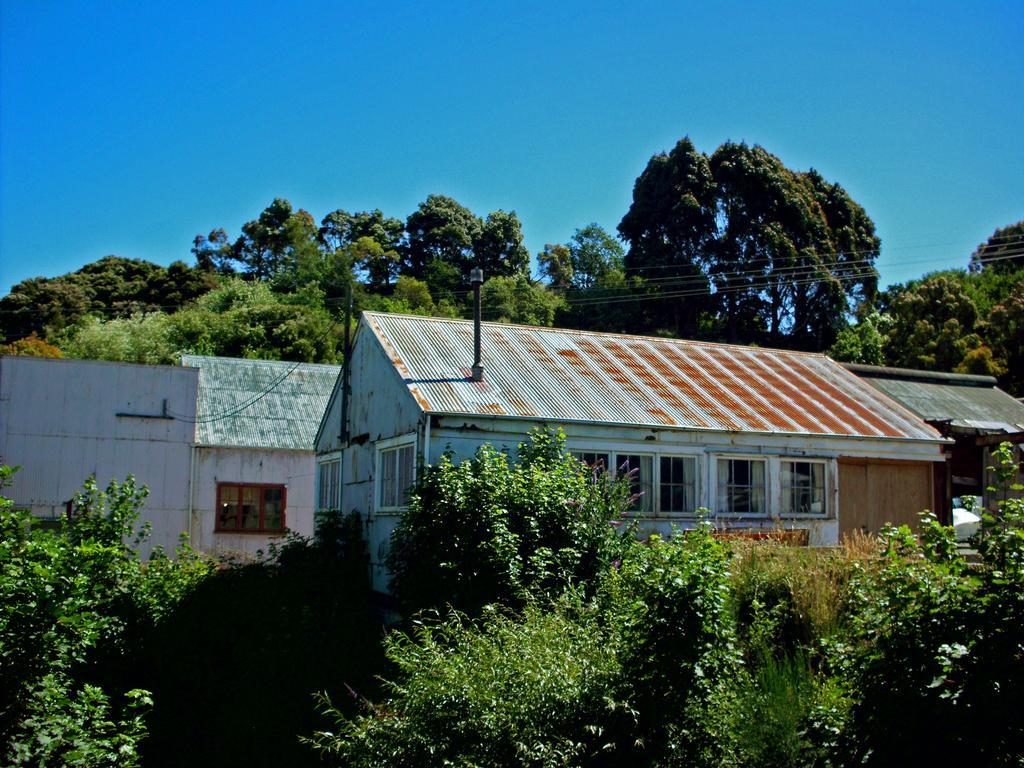Describe this image in one or two sentences. In this image I can see houses and in front of houses I can see plants and bushes ,at the top I can see trees and power line cables and the sky visible. 